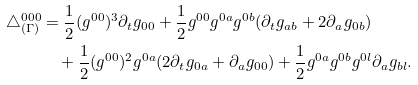Convert formula to latex. <formula><loc_0><loc_0><loc_500><loc_500>\triangle _ { ( \Gamma ) } ^ { 0 0 0 } & = \frac { 1 } { 2 } ( g ^ { 0 0 } ) ^ { 3 } \partial _ { t } g _ { 0 0 } + \frac { 1 } { 2 } g ^ { 0 0 } g ^ { 0 a } g ^ { 0 b } ( \partial _ { t } g _ { a b } + 2 \partial _ { a } g _ { 0 b } ) \\ & \quad + \frac { 1 } { 2 } ( g ^ { 0 0 } ) ^ { 2 } g ^ { 0 a } ( 2 \partial _ { t } g _ { 0 a } + \partial _ { a } g _ { 0 0 } ) + \frac { 1 } { 2 } g ^ { 0 a } g ^ { 0 b } g ^ { 0 l } \partial _ { a } g _ { b l } .</formula> 